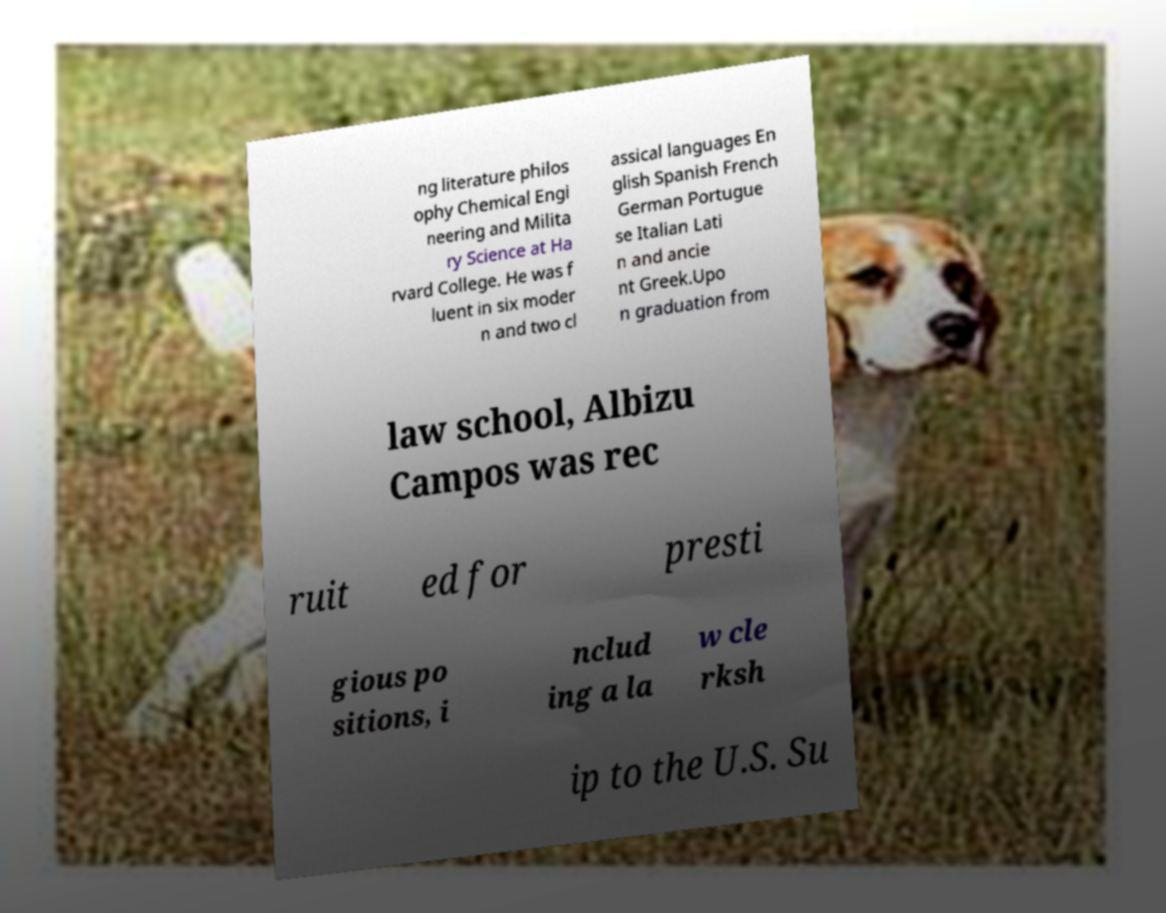Can you read and provide the text displayed in the image?This photo seems to have some interesting text. Can you extract and type it out for me? ng literature philos ophy Chemical Engi neering and Milita ry Science at Ha rvard College. He was f luent in six moder n and two cl assical languages En glish Spanish French German Portugue se Italian Lati n and ancie nt Greek.Upo n graduation from law school, Albizu Campos was rec ruit ed for presti gious po sitions, i nclud ing a la w cle rksh ip to the U.S. Su 